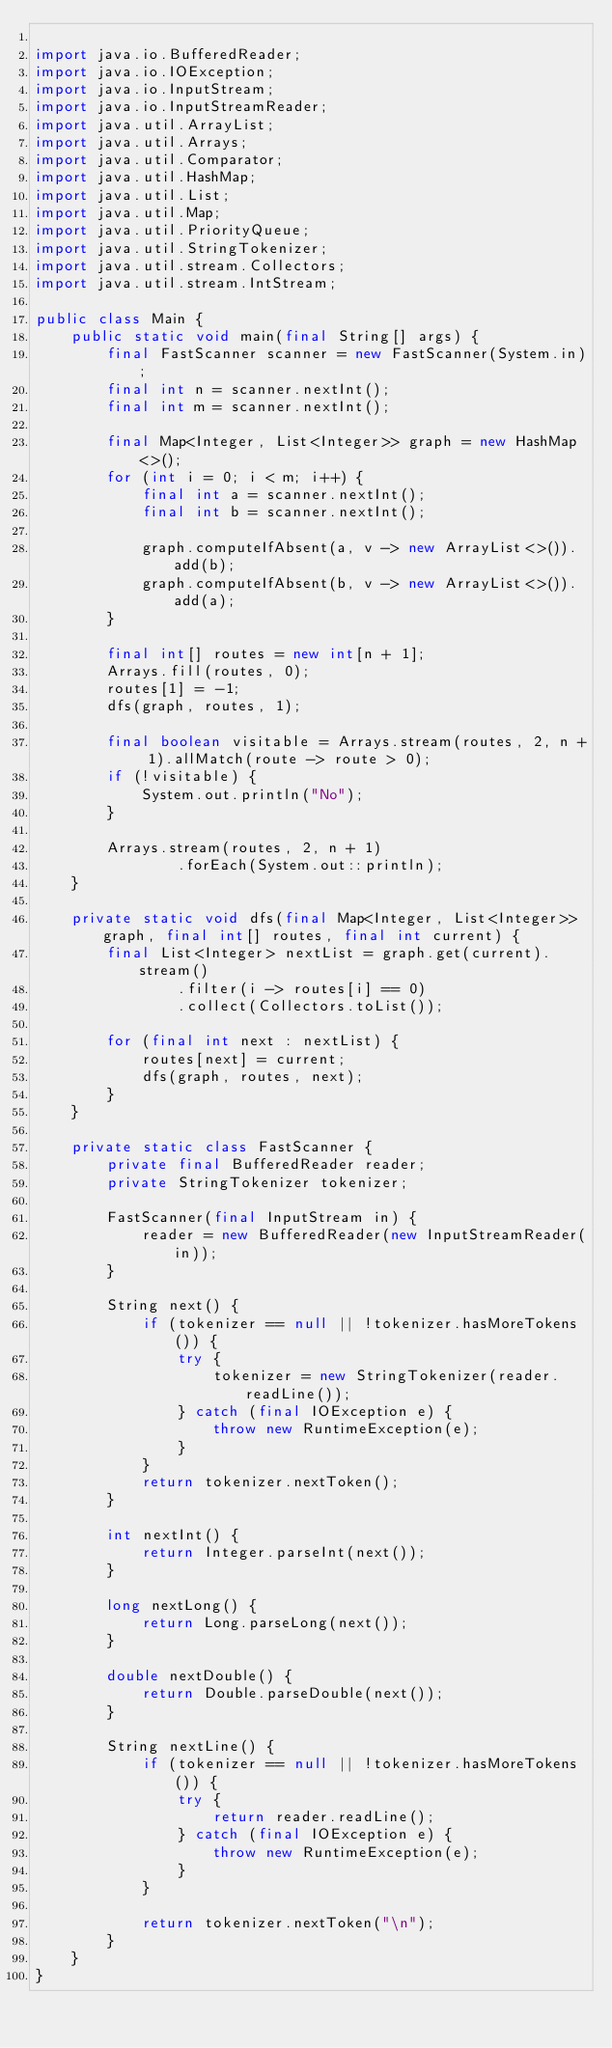Convert code to text. <code><loc_0><loc_0><loc_500><loc_500><_Java_>
import java.io.BufferedReader;
import java.io.IOException;
import java.io.InputStream;
import java.io.InputStreamReader;
import java.util.ArrayList;
import java.util.Arrays;
import java.util.Comparator;
import java.util.HashMap;
import java.util.List;
import java.util.Map;
import java.util.PriorityQueue;
import java.util.StringTokenizer;
import java.util.stream.Collectors;
import java.util.stream.IntStream;

public class Main {
    public static void main(final String[] args) {
        final FastScanner scanner = new FastScanner(System.in);
        final int n = scanner.nextInt();
        final int m = scanner.nextInt();

        final Map<Integer, List<Integer>> graph = new HashMap<>();
        for (int i = 0; i < m; i++) {
            final int a = scanner.nextInt();
            final int b = scanner.nextInt();

            graph.computeIfAbsent(a, v -> new ArrayList<>()).add(b);
            graph.computeIfAbsent(b, v -> new ArrayList<>()).add(a);
        }

        final int[] routes = new int[n + 1];
        Arrays.fill(routes, 0);
        routes[1] = -1;
        dfs(graph, routes, 1);

        final boolean visitable = Arrays.stream(routes, 2, n + 1).allMatch(route -> route > 0);
        if (!visitable) {
            System.out.println("No");
        }

        Arrays.stream(routes, 2, n + 1)
                .forEach(System.out::println);
    }

    private static void dfs(final Map<Integer, List<Integer>> graph, final int[] routes, final int current) {
        final List<Integer> nextList = graph.get(current).stream()
                .filter(i -> routes[i] == 0)
                .collect(Collectors.toList());

        for (final int next : nextList) {
            routes[next] = current;
            dfs(graph, routes, next);
        }
    }

    private static class FastScanner {
        private final BufferedReader reader;
        private StringTokenizer tokenizer;

        FastScanner(final InputStream in) {
            reader = new BufferedReader(new InputStreamReader(in));
        }

        String next() {
            if (tokenizer == null || !tokenizer.hasMoreTokens()) {
                try {
                    tokenizer = new StringTokenizer(reader.readLine());
                } catch (final IOException e) {
                    throw new RuntimeException(e);
                }
            }
            return tokenizer.nextToken();
        }

        int nextInt() {
            return Integer.parseInt(next());
        }

        long nextLong() {
            return Long.parseLong(next());
        }

        double nextDouble() {
            return Double.parseDouble(next());
        }

        String nextLine() {
            if (tokenizer == null || !tokenizer.hasMoreTokens()) {
                try {
                    return reader.readLine();
                } catch (final IOException e) {
                    throw new RuntimeException(e);
                }
            }

            return tokenizer.nextToken("\n");
        }
    }
}
</code> 